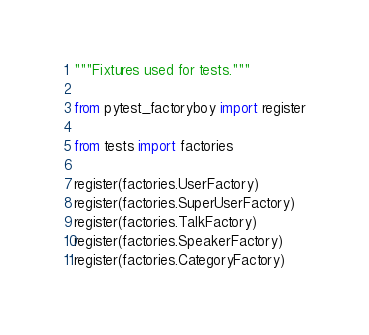<code> <loc_0><loc_0><loc_500><loc_500><_Python_>"""Fixtures used for tests."""

from pytest_factoryboy import register

from tests import factories

register(factories.UserFactory)
register(factories.SuperUserFactory)
register(factories.TalkFactory)
register(factories.SpeakerFactory)
register(factories.CategoryFactory)
</code> 